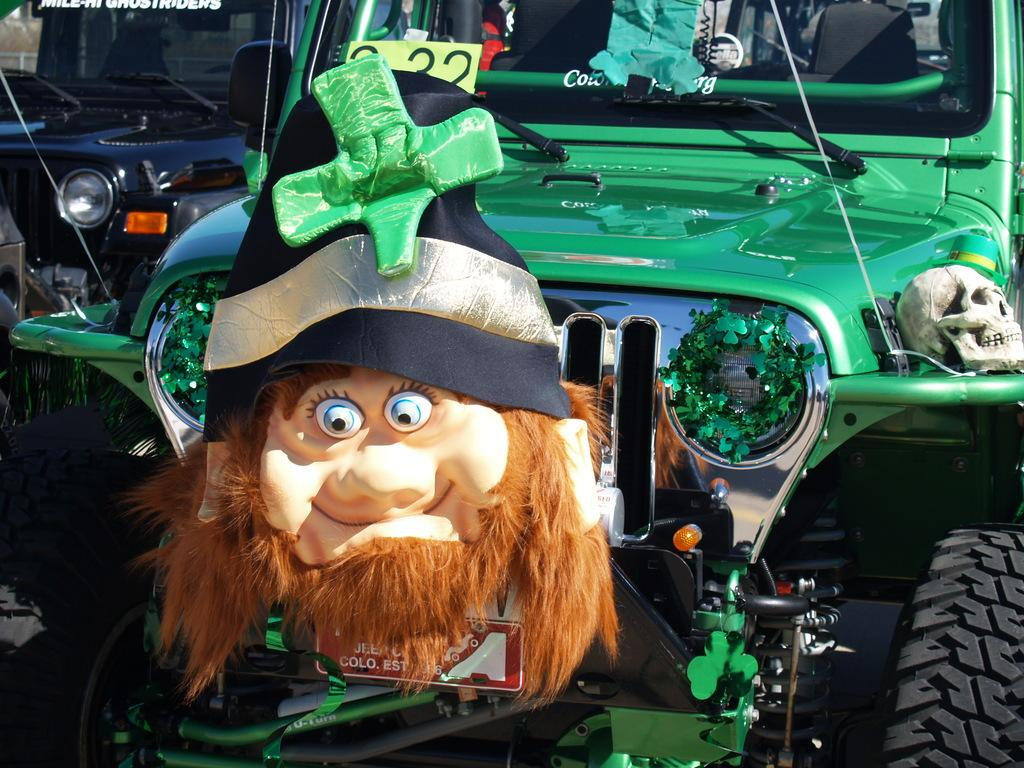What is the main subject in the center of the image? There is a toy car in the center of the image. Can you describe the vehicle in the background of the image? There is a black color jeep in the background of the image. How many dinosaurs can be seen playing with the toy car in the image? There are no dinosaurs present in the image; it features a toy car and a black color jeep. What achievement is the toy car celebrating in the image? The toy car is not celebrating any achievement in the image; it is simply a toy car in the center of the image. 